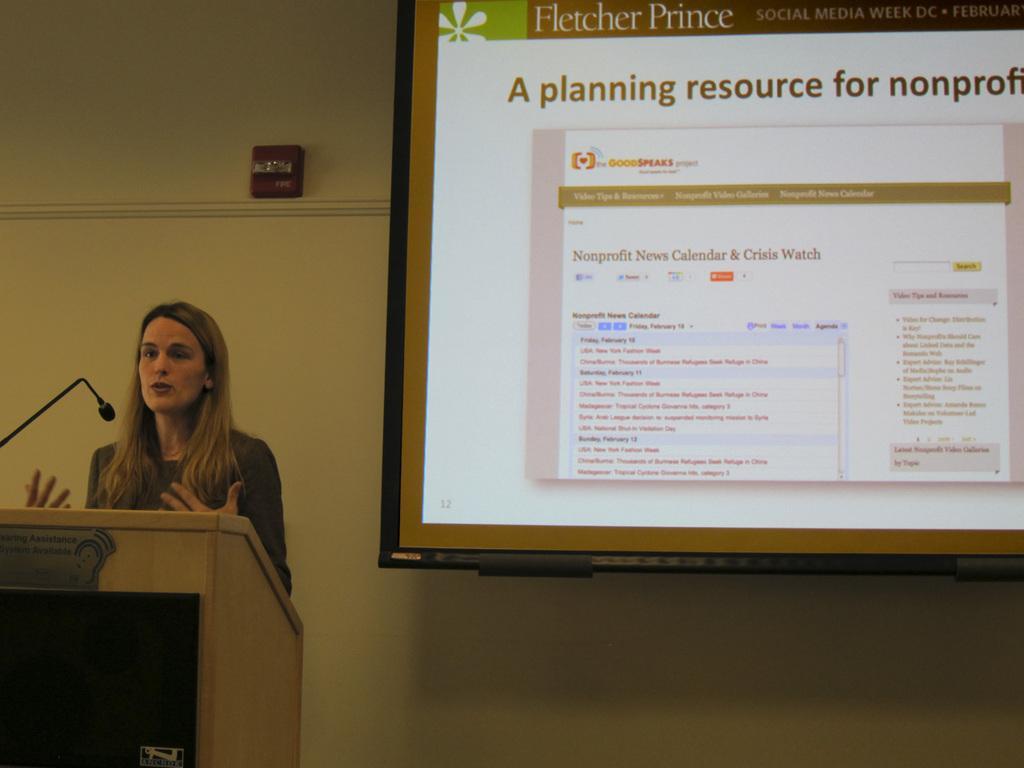In one or two sentences, can you explain what this image depicts? In this image on the left side there is one woman who is talking, in front of her there is podium and mike and on the right side there is a screen on the wall. 